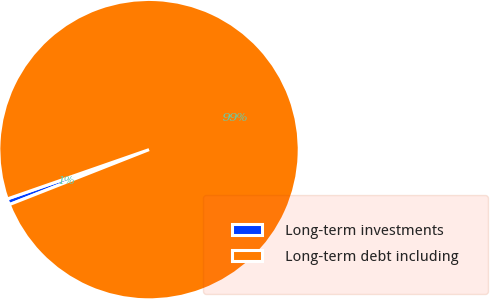<chart> <loc_0><loc_0><loc_500><loc_500><pie_chart><fcel>Long-term investments<fcel>Long-term debt including<nl><fcel>0.64%<fcel>99.36%<nl></chart> 